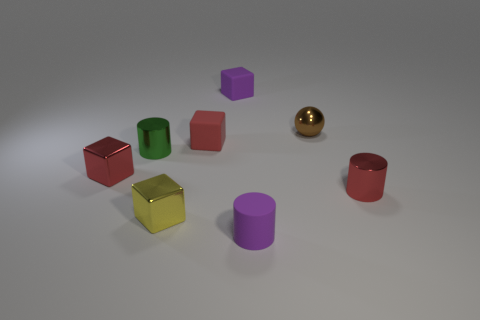What size is the red cylinder on the right side of the tiny green shiny cylinder?
Ensure brevity in your answer.  Small. There is a tiny purple object in front of the small red thing that is behind the green metal cylinder; what shape is it?
Offer a very short reply. Cylinder. What number of tiny red things are in front of the tiny metal cube behind the small metallic cylinder that is to the right of the red matte object?
Provide a succinct answer. 1. Are there fewer cylinders that are right of the yellow block than red blocks?
Provide a succinct answer. No. Is there any other thing that is the same shape as the tiny green metal thing?
Your answer should be compact. Yes. There is a purple matte object to the left of the purple cylinder; what is its shape?
Make the answer very short. Cube. What is the shape of the purple rubber thing that is in front of the small red shiny object on the right side of the tiny cylinder on the left side of the purple cylinder?
Your response must be concise. Cylinder. How many things are either tiny metallic cylinders or yellow metallic blocks?
Give a very brief answer. 3. Does the purple rubber object that is behind the yellow shiny block have the same shape as the purple matte thing in front of the red shiny cylinder?
Offer a terse response. No. How many tiny cubes are both right of the red metal cube and in front of the purple rubber block?
Your response must be concise. 2. 